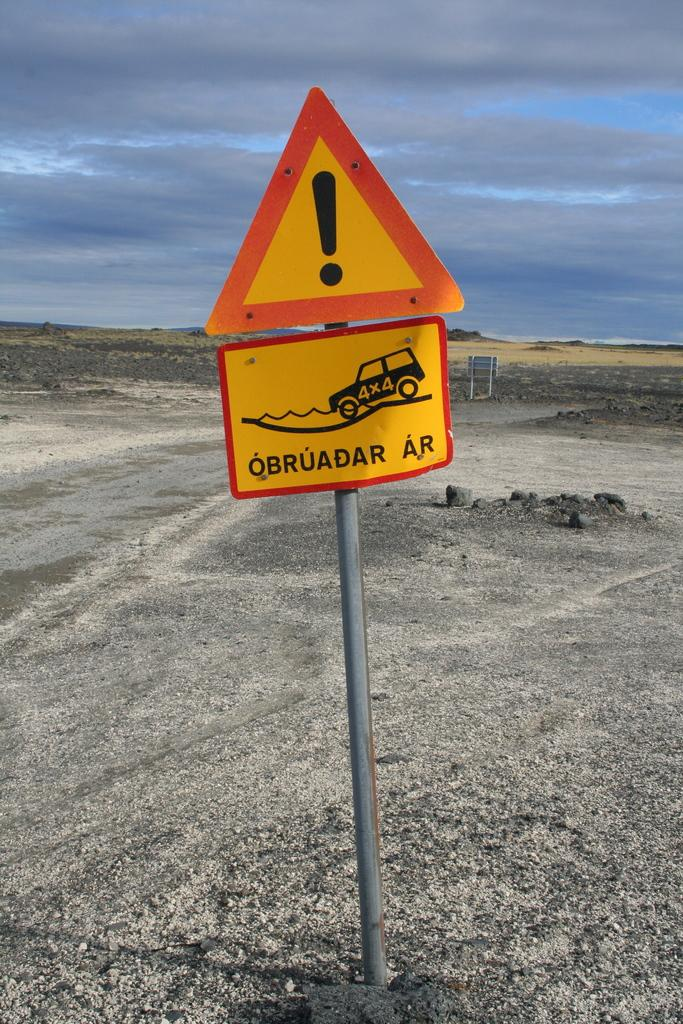<image>
Share a concise interpretation of the image provided. A sign below a triangle sign has the words OBRUADAR AR. 